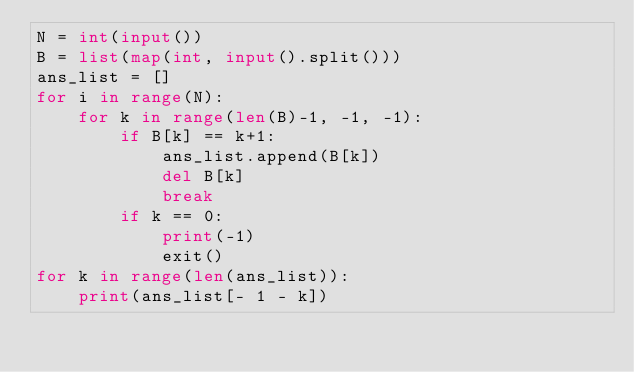Convert code to text. <code><loc_0><loc_0><loc_500><loc_500><_Python_>N = int(input())
B = list(map(int, input().split()))
ans_list = []
for i in range(N):
    for k in range(len(B)-1, -1, -1):
        if B[k] == k+1:
            ans_list.append(B[k])
            del B[k]
            break
        if k == 0:
            print(-1)
            exit()
for k in range(len(ans_list)):
    print(ans_list[- 1 - k])</code> 